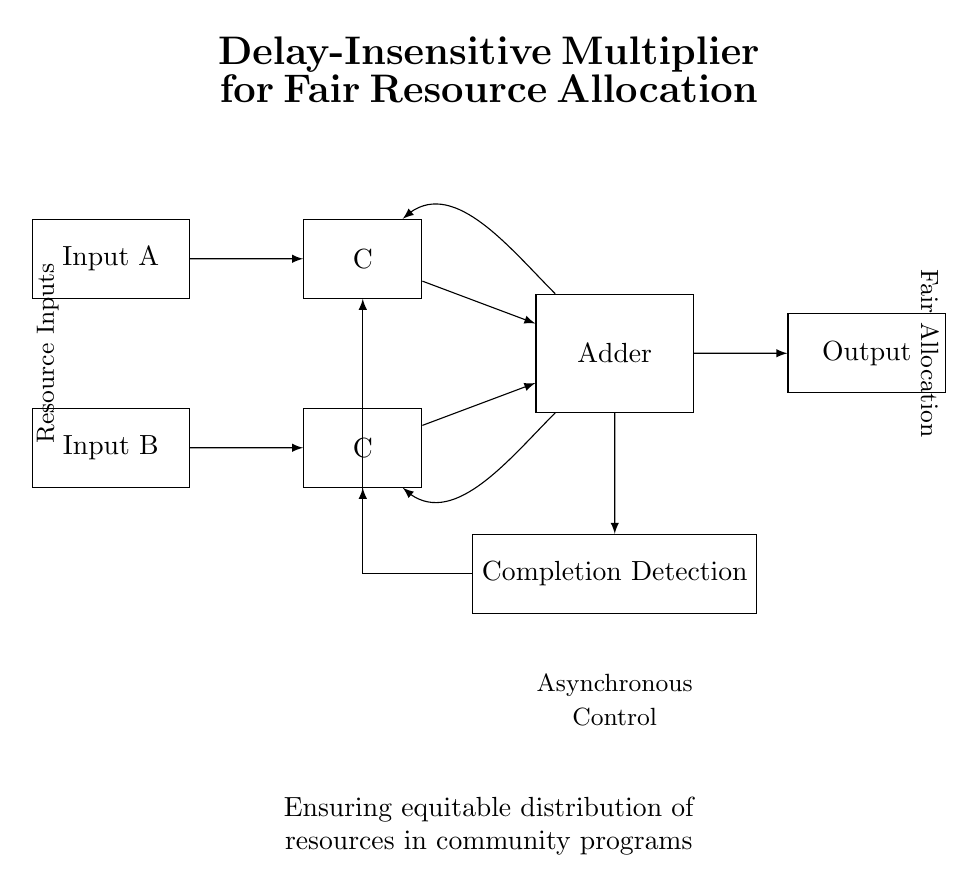What components are present in this circuit? The circuit contains Input registers, Muller C-elements, an Adder, an Output register, and a Completion Detection unit.
Answer: Input registers, Muller C-elements, Adder, Output register, Completion Detection What is the purpose of the Completion Detection unit? The Completion Detection unit is responsible for confirming when the addition operation is finished and sending feedback to the Muller C-elements.
Answer: To confirm completion of addition How many Input registers are there? There are two Input registers labeled Input A and Input B.
Answer: Two What type of multiplier does this circuit implement? The circuit implements a delay-insensitive multiplier, which allows for fair resource allocation without timing constraints.
Answer: Delay-insensitive How do the outputs connect to the Completion Detection unit? The output from the Adder goes to the Completion Detection, and the Completion Detection feeds back to both Muller C-elements, indicating when the operation is complete.
Answer: Through a feedback loop What is the significance of the feedback paths in this circuit? The feedback paths are essential for ensuring that the input changes from the Adder can influence the Muller C-elements, maintaining the asynchronous nature of the circuit.
Answer: To maintain asynchronous operation 